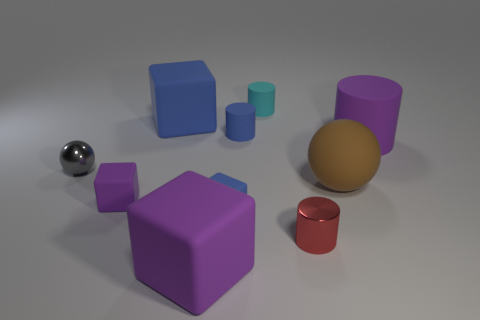What is the large purple cylinder made of?
Your response must be concise. Rubber. The big thing in front of the small red object is what color?
Provide a short and direct response. Purple. Are there more tiny cylinders that are behind the tiny red object than things that are left of the small sphere?
Offer a terse response. Yes. There is a metallic thing that is right of the small thing that is behind the blue rubber block behind the large cylinder; what is its size?
Your answer should be very brief. Small. Are there any matte things that have the same color as the shiny sphere?
Make the answer very short. No. How many tiny green shiny cubes are there?
Offer a very short reply. 0. There is a blue cube that is on the right side of the big block that is in front of the cube behind the large purple matte cylinder; what is its material?
Offer a terse response. Rubber. Is there a blue cube that has the same material as the gray thing?
Offer a very short reply. No. Is the purple cylinder made of the same material as the small blue cylinder?
Your answer should be very brief. Yes. How many cylinders are big green rubber things or cyan things?
Your response must be concise. 1. 